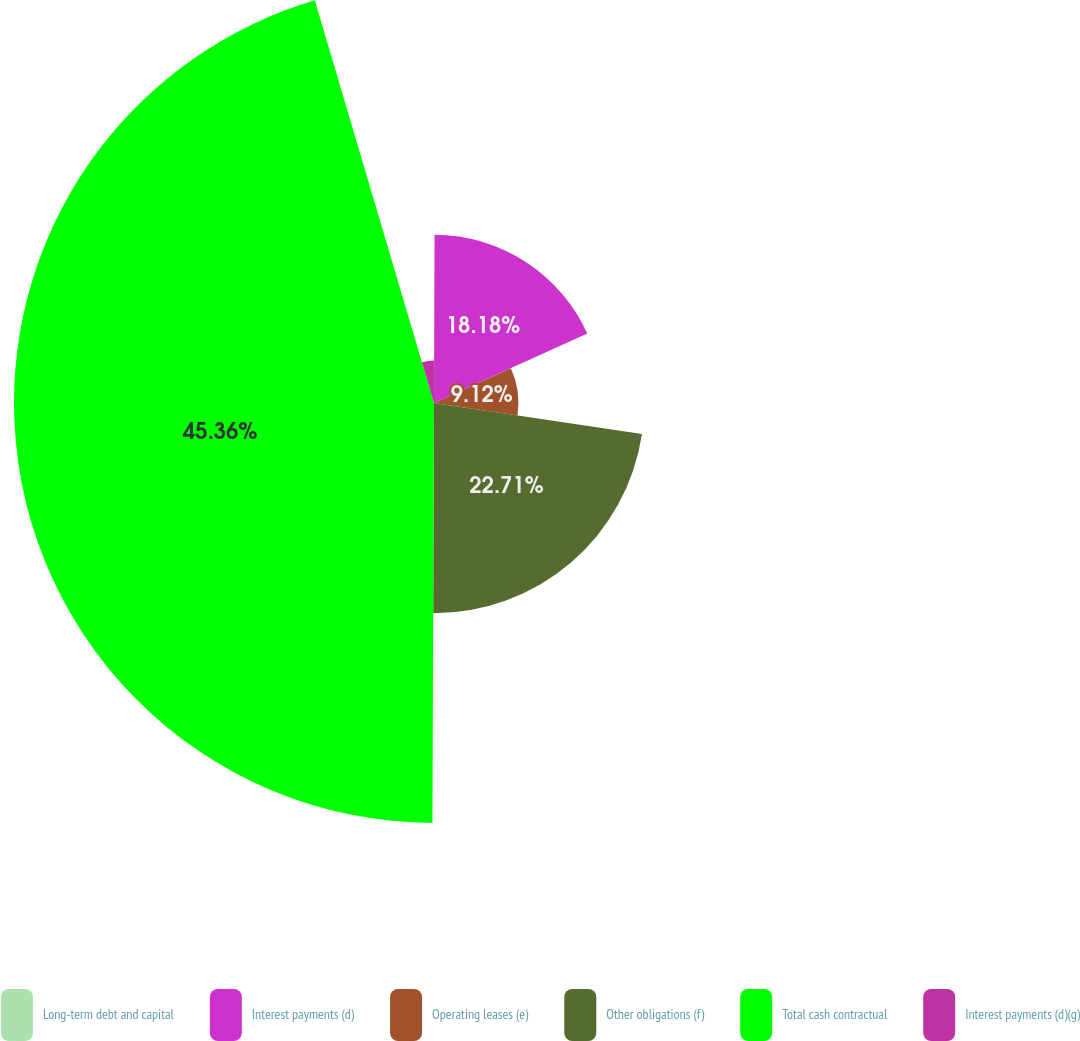Convert chart to OTSL. <chart><loc_0><loc_0><loc_500><loc_500><pie_chart><fcel>Long-term debt and capital<fcel>Interest payments (d)<fcel>Operating leases (e)<fcel>Other obligations (f)<fcel>Total cash contractual<fcel>Interest payments (d)(g)<nl><fcel>0.05%<fcel>18.18%<fcel>9.12%<fcel>22.71%<fcel>45.36%<fcel>4.58%<nl></chart> 